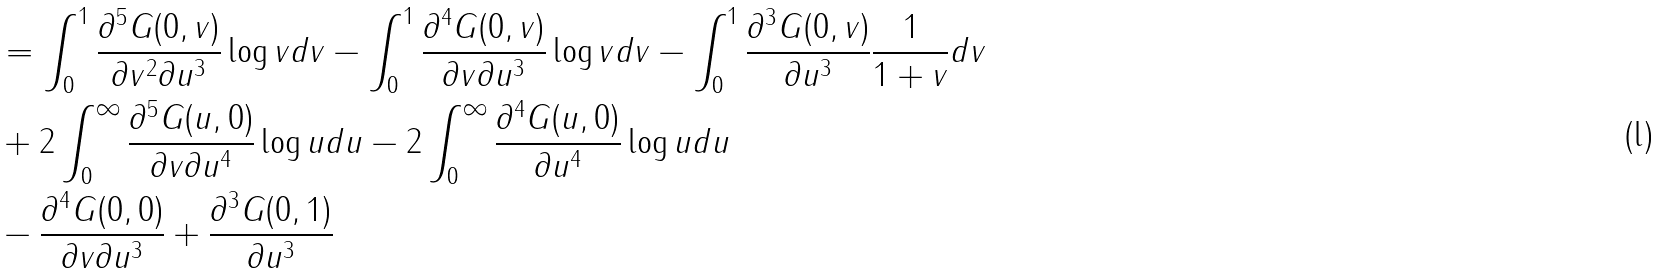Convert formula to latex. <formula><loc_0><loc_0><loc_500><loc_500>& = \int _ { 0 } ^ { 1 } \frac { \partial ^ { 5 } G ( 0 , v ) } { \partial v ^ { 2 } \partial u ^ { 3 } } \log v d v - \int _ { 0 } ^ { 1 } \frac { \partial ^ { 4 } G ( 0 , v ) } { \partial v \partial u ^ { 3 } } \log v d v - \int _ { 0 } ^ { 1 } \frac { \partial ^ { 3 } G ( 0 , v ) } { \partial u ^ { 3 } } \frac { 1 } { 1 + v } d v \\ & + 2 \int _ { 0 } ^ { \infty } \frac { \partial ^ { 5 } G ( u , 0 ) } { \partial v \partial u ^ { 4 } } \log u d u - 2 \int _ { 0 } ^ { \infty } \frac { \partial ^ { 4 } G ( u , 0 ) } { \partial u ^ { 4 } } \log u d u \\ & - \frac { \partial ^ { 4 } G ( 0 , 0 ) } { \partial v \partial u ^ { 3 } } + \frac { \partial ^ { 3 } G ( 0 , 1 ) } { \partial u ^ { 3 } }</formula> 